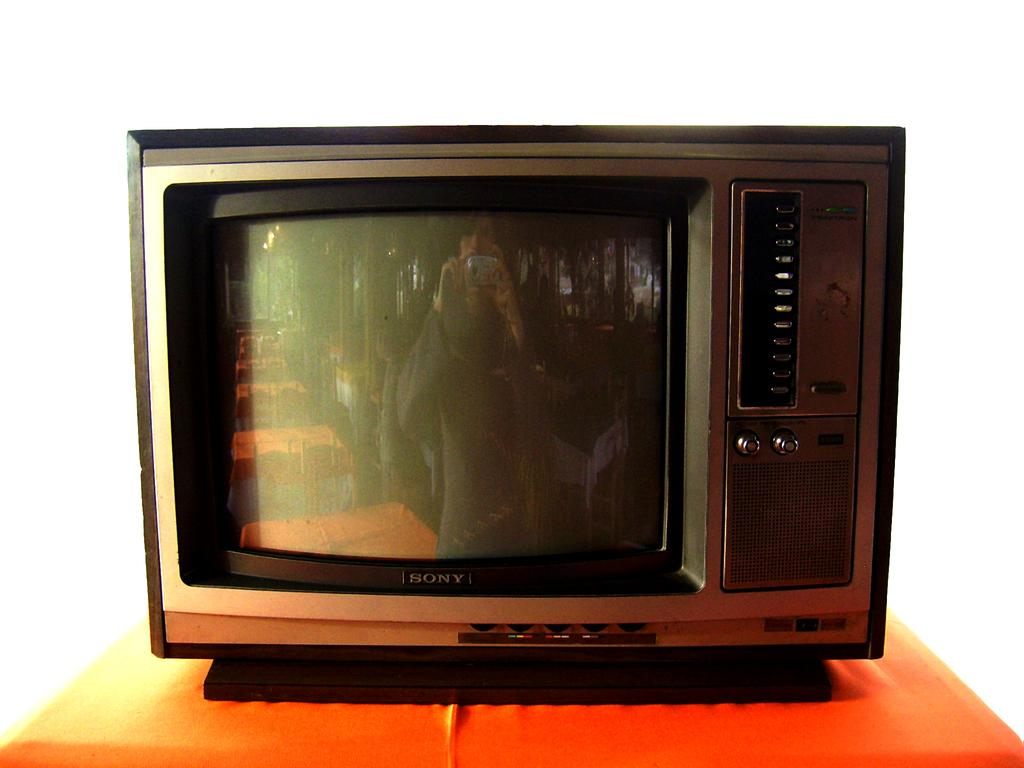<image>
Describe the image concisely. an old Sony television on a wooden table 